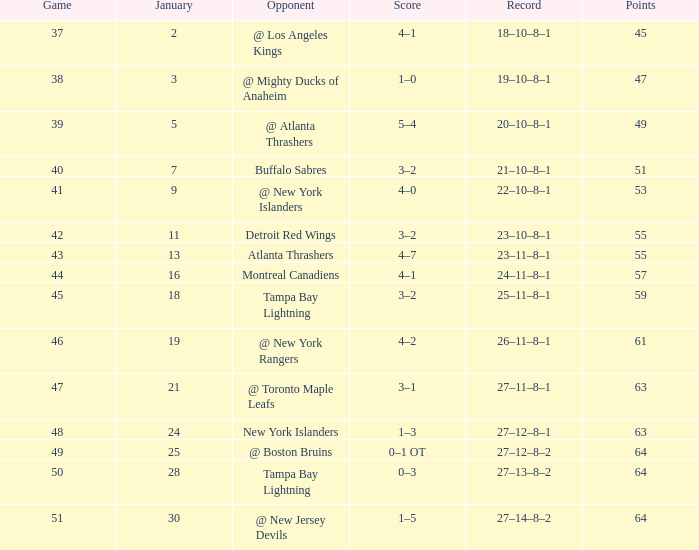How many Games have a Score of 5–4, and Points smaller than 49? 0.0. I'm looking to parse the entire table for insights. Could you assist me with that? {'header': ['Game', 'January', 'Opponent', 'Score', 'Record', 'Points'], 'rows': [['37', '2', '@ Los Angeles Kings', '4–1', '18–10–8–1', '45'], ['38', '3', '@ Mighty Ducks of Anaheim', '1–0', '19–10–8–1', '47'], ['39', '5', '@ Atlanta Thrashers', '5–4', '20–10–8–1', '49'], ['40', '7', 'Buffalo Sabres', '3–2', '21–10–8–1', '51'], ['41', '9', '@ New York Islanders', '4–0', '22–10–8–1', '53'], ['42', '11', 'Detroit Red Wings', '3–2', '23–10–8–1', '55'], ['43', '13', 'Atlanta Thrashers', '4–7', '23–11–8–1', '55'], ['44', '16', 'Montreal Canadiens', '4–1', '24–11–8–1', '57'], ['45', '18', 'Tampa Bay Lightning', '3–2', '25–11–8–1', '59'], ['46', '19', '@ New York Rangers', '4–2', '26–11–8–1', '61'], ['47', '21', '@ Toronto Maple Leafs', '3–1', '27–11–8–1', '63'], ['48', '24', 'New York Islanders', '1–3', '27–12–8–1', '63'], ['49', '25', '@ Boston Bruins', '0–1 OT', '27–12–8–2', '64'], ['50', '28', 'Tampa Bay Lightning', '0–3', '27–13–8–2', '64'], ['51', '30', '@ New Jersey Devils', '1–5', '27–14–8–2', '64']]} 